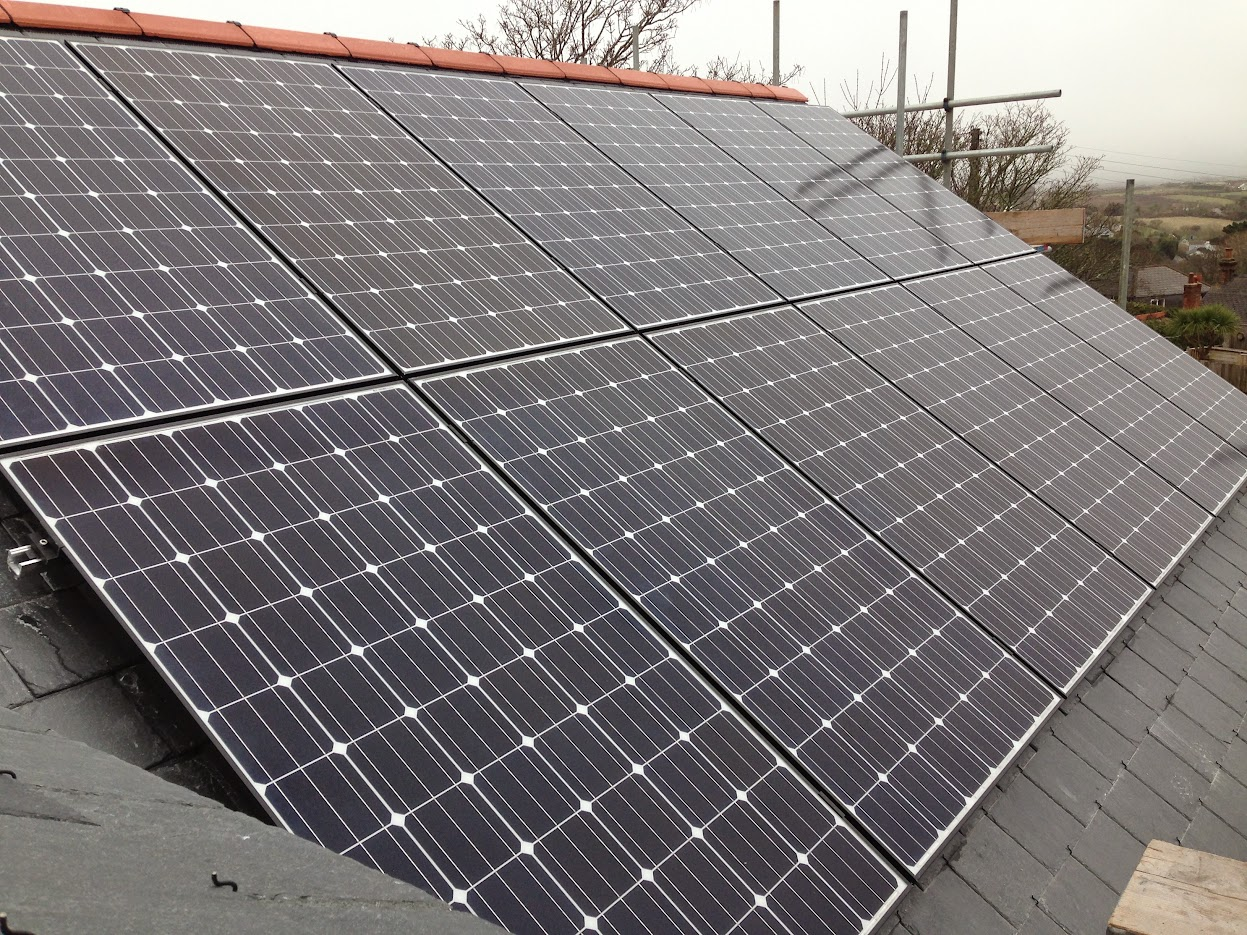What might be the estimated capacity of the solar panel installation based on the number of panels visible in the image? While a precise capacity estimate is challenging without details on panel make or specific wattage, a basic estimation can be attempted. Counting approximately 20 visible panels, and assuming a commonly used wattage of around 250 watts per panel, the system might provide about 5 kilowatts. Nonetheless, it's crucial to remember this is a speculative calculation. Factors like panel orientation, geographic location, and the specific technology (e.g., monocrystalline or polycrystalline) can also influence the overall efficiency and output. 